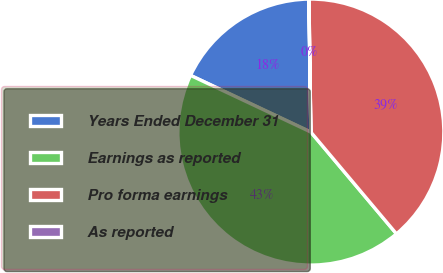Convert chart. <chart><loc_0><loc_0><loc_500><loc_500><pie_chart><fcel>Years Ended December 31<fcel>Earnings as reported<fcel>Pro forma earnings<fcel>As reported<nl><fcel>17.75%<fcel>43.14%<fcel>39.09%<fcel>0.02%<nl></chart> 